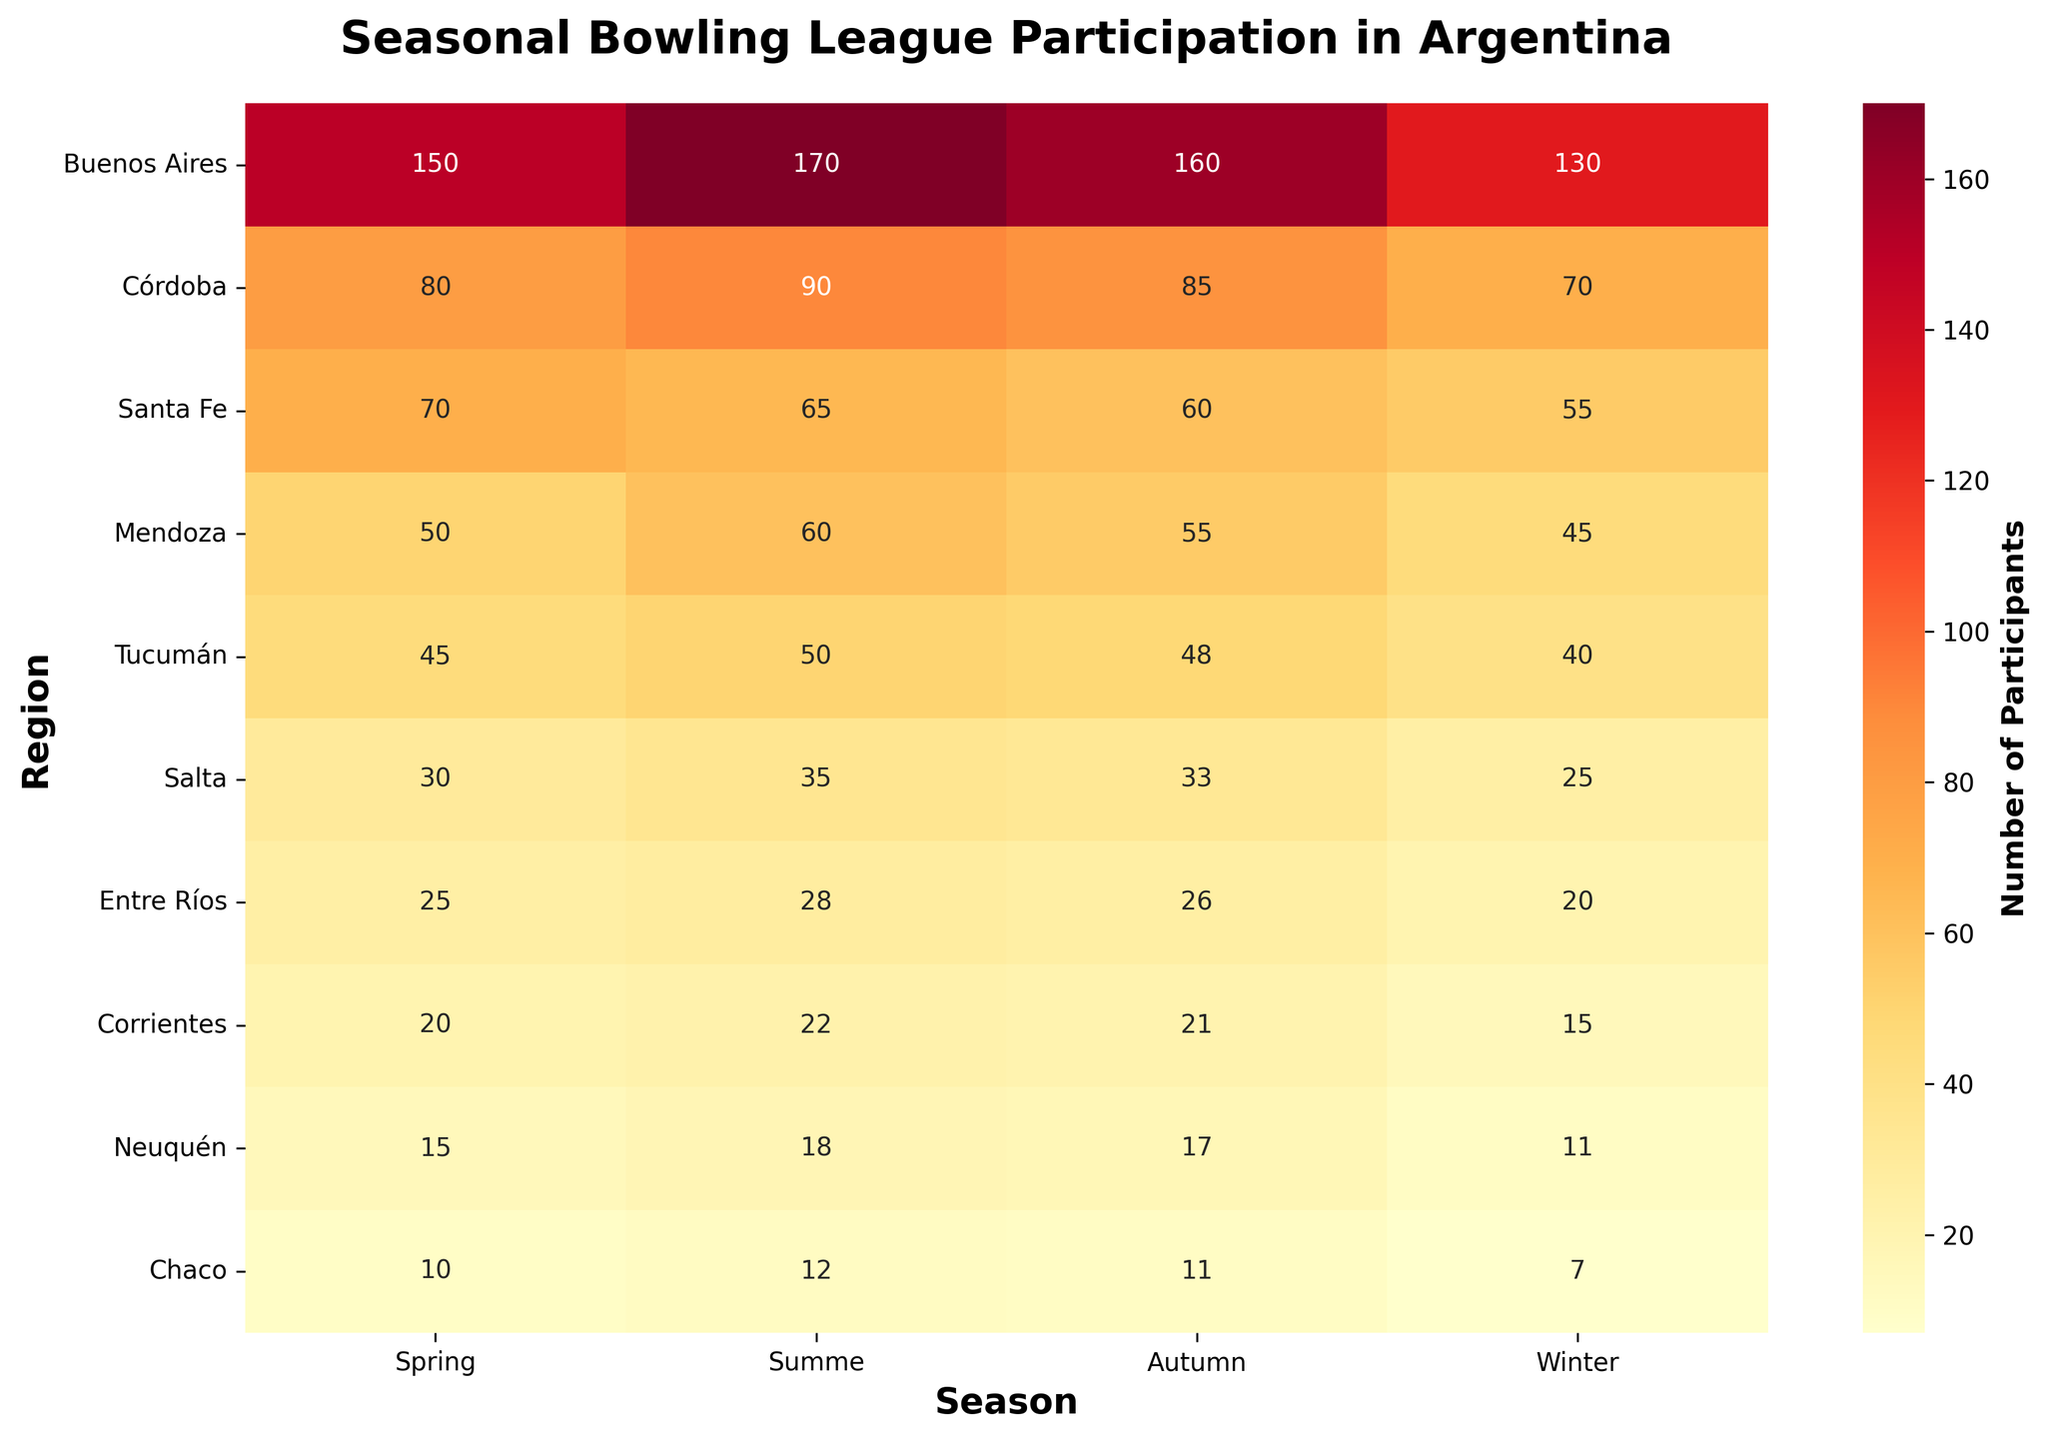What's the title of the heatmap? The title is located at the top of the plot and is bold and large, making it easy to read.
Answer: Seasonal Bowling League Participation in Argentina Which region has the highest bowling participation during Summer? Look for the highest number in the Summer column. Buenos Aires has 170 participants, which is the highest.
Answer: Buenos Aires What's the total number of participants in Autumn across all regions? Sum the numbers in the Autumn column: 160 + 85 + 60 + 55 + 48 + 33 + 26 + 21 + 17 + 11 = 516.
Answer: 516 How does the participation in Winter in Tucumán compare to the participation in Winter in Buenos Aires? Check the Winter column for both regions. Tucumán has 40 participants while Buenos Aires has 130. Therefore, Buenos Aires has more participants.
Answer: Buenos Aires has more Which season has the lowest average participation across all regions? Calculate the averages for each season and compare: Spring (495/10 = 49.5), Summer (550/10 = 55), Autumn (515/10 = 51.5), Winter (433/10 = 43.3). Winter has the lowest average.
Answer: Winter Is there any region where participation is consistently increasing from Spring to Winter? Check each region row by row to see if the numbers keep increasing from Spring to Winter. Every region shows a decrease at some point.
Answer: No How many more participants are there in Córdoba during Spring compared to Winter? Subtract the number in Winter from the number in Spring for Córdoba: 80 - 70 = 10.
Answer: 10 Which region has the least participation in Spring? Find the smallest number in the Spring column. Chaco has the lowest with 10 participants.
Answer: Chaco What's the difference in the total number of participants between Buenos Aires and Corrientes in Summer? Subtract the number in Corrientes in Summer from the number in Buenos Aires in Summer: 170 - 22 = 148.
Answer: 148 In which season does Salta have the highest participation? Look at Salta's row and find the highest number across all seasons. Salta has the highest participation in Summer with 35 participants.
Answer: Summer 